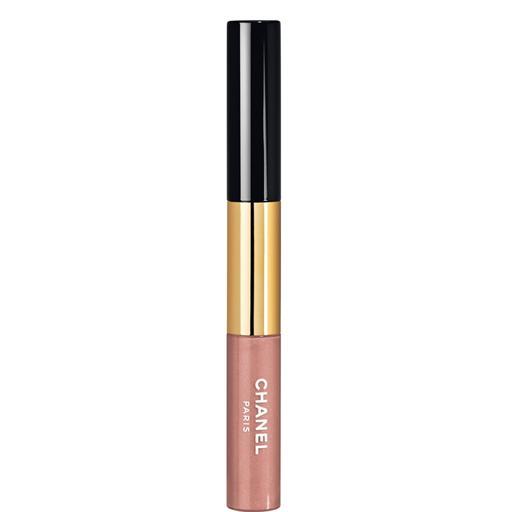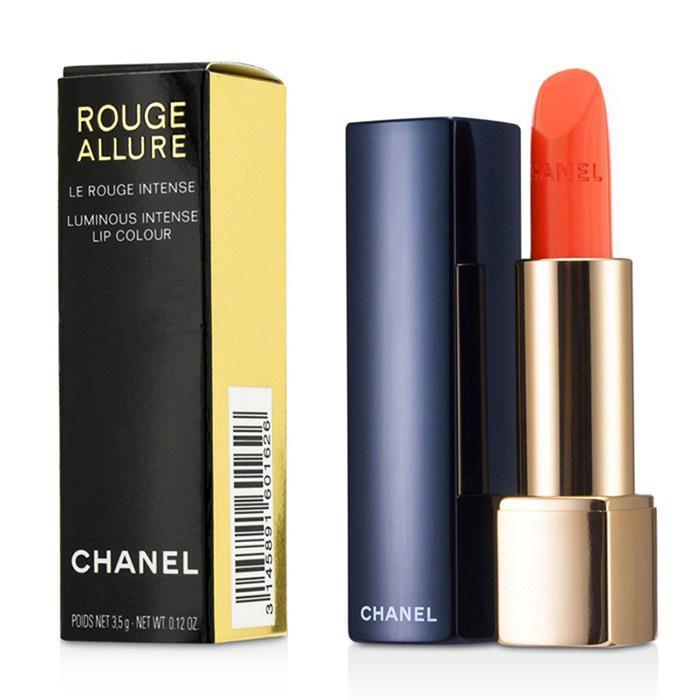The first image is the image on the left, the second image is the image on the right. Evaluate the accuracy of this statement regarding the images: "One image contains a single lipstick next to its lid, and the other image contains multiple lipsticks next to their lids.". Is it true? Answer yes or no. No. The first image is the image on the left, the second image is the image on the right. Evaluate the accuracy of this statement regarding the images: "There are more than one lipsticks in one of the images.". Is it true? Answer yes or no. No. 